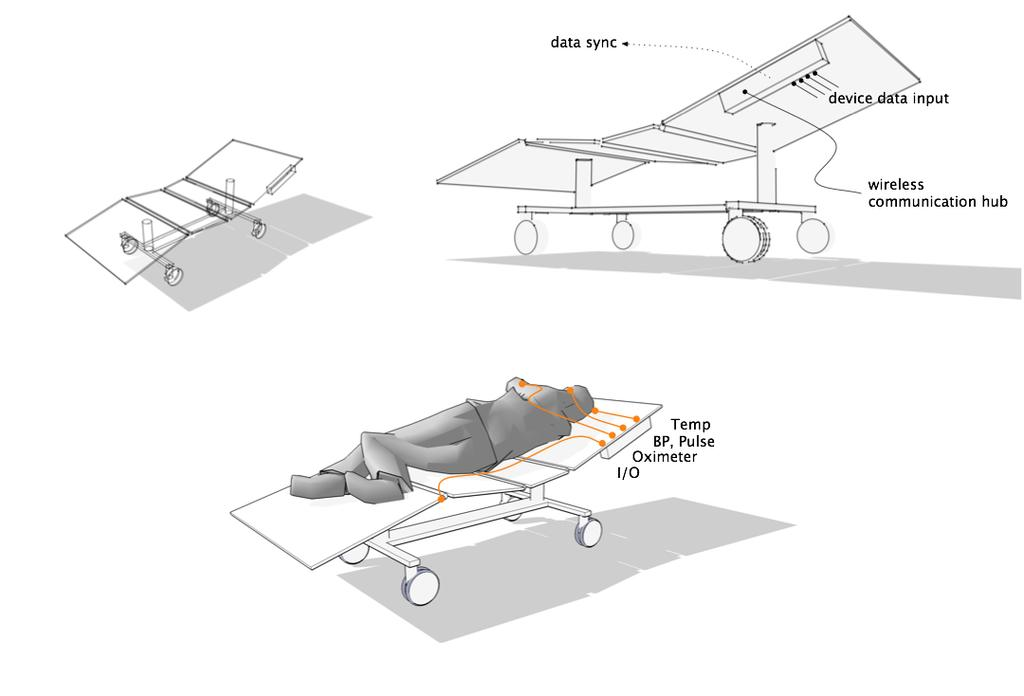What is the main subject of the drawing in the image? The drawing depicts a person lying on a wheel bed. Are there any other wheel beds in the drawing? Yes, there are two more wheel beds in the drawing. Is there any text present in the drawing? Yes, there is some text in the drawing. What type of cough medicine is depicted in the drawing? There is no cough medicine present in the drawing; it depicts a person lying on a wheel bed and other wheel beds. 